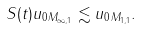<formula> <loc_0><loc_0><loc_500><loc_500>\| S ( t ) u _ { 0 } \| _ { M _ { \infty , 1 } } \lesssim \| u _ { 0 } \| _ { M _ { 1 , 1 } } .</formula> 